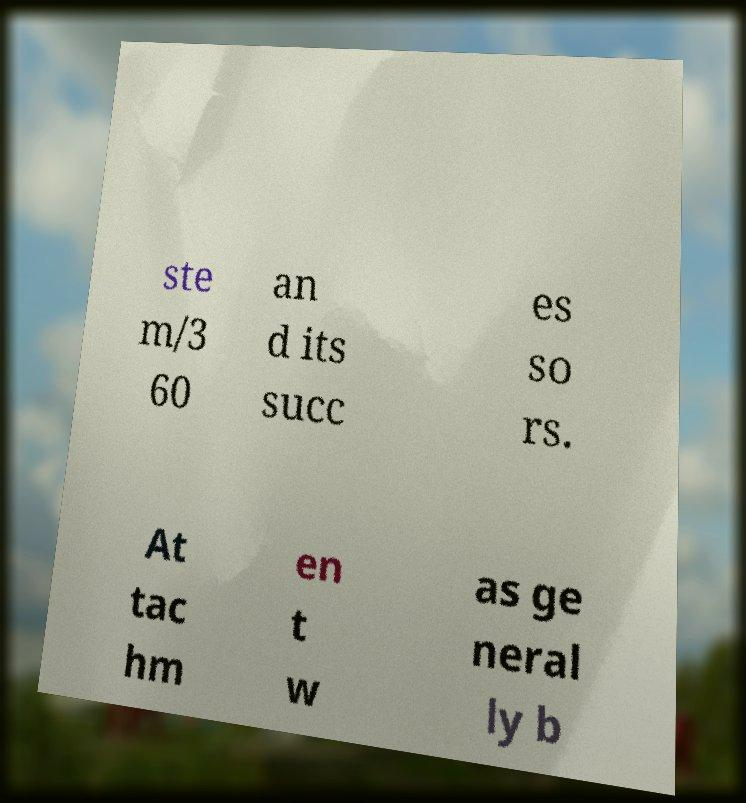There's text embedded in this image that I need extracted. Can you transcribe it verbatim? ste m/3 60 an d its succ es so rs. At tac hm en t w as ge neral ly b 